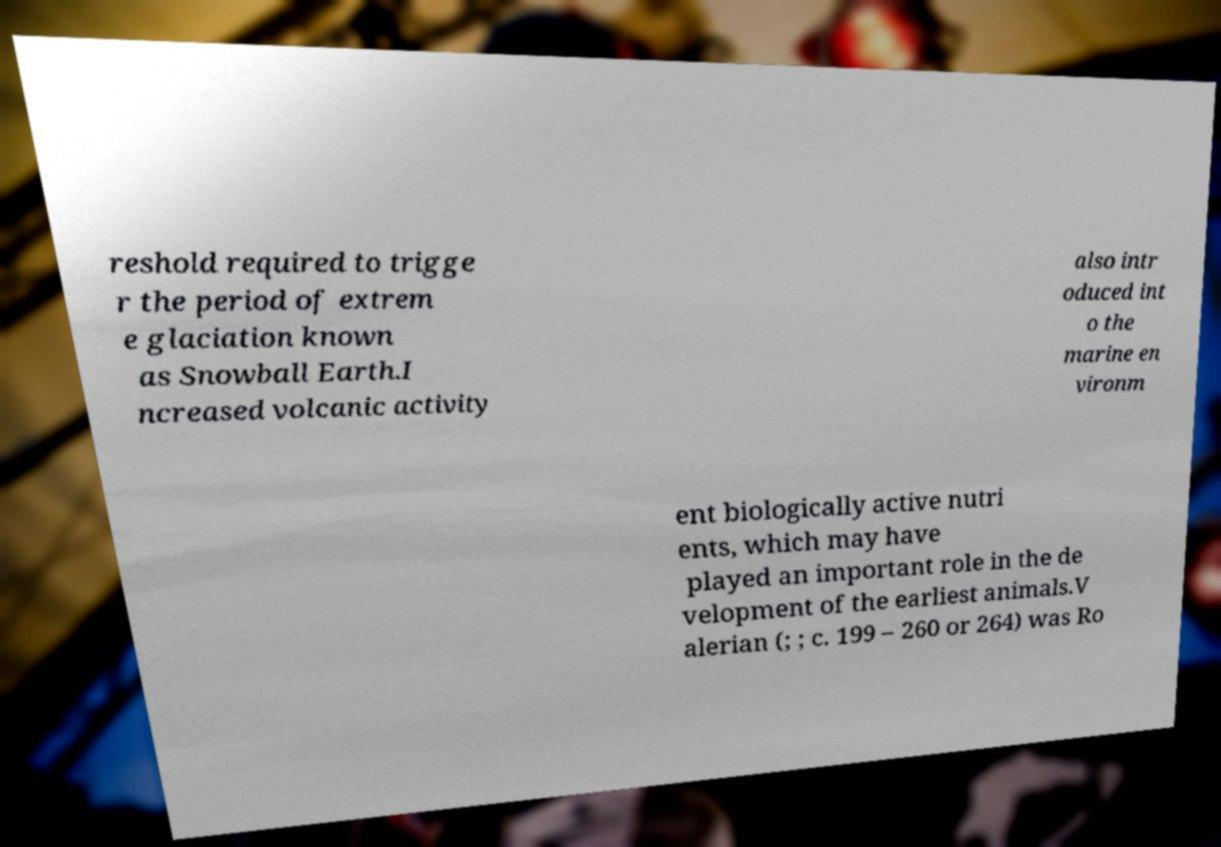Could you assist in decoding the text presented in this image and type it out clearly? reshold required to trigge r the period of extrem e glaciation known as Snowball Earth.I ncreased volcanic activity also intr oduced int o the marine en vironm ent biologically active nutri ents, which may have played an important role in the de velopment of the earliest animals.V alerian (; ; c. 199 – 260 or 264) was Ro 